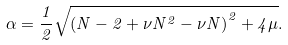Convert formula to latex. <formula><loc_0><loc_0><loc_500><loc_500>\alpha = \frac { 1 } { 2 } \sqrt { { ( N - 2 + \nu N ^ { 2 } - \nu N ) } ^ { 2 } + 4 \mu } .</formula> 